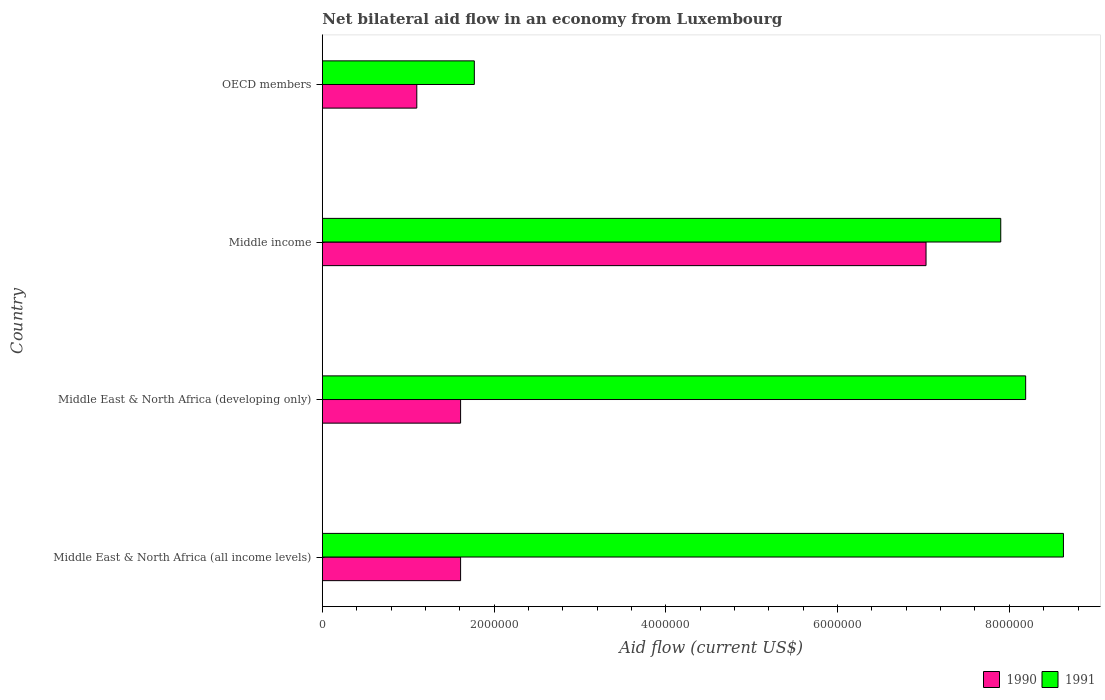How many different coloured bars are there?
Your answer should be compact. 2. How many groups of bars are there?
Your answer should be compact. 4. Are the number of bars per tick equal to the number of legend labels?
Give a very brief answer. Yes. How many bars are there on the 2nd tick from the bottom?
Provide a short and direct response. 2. What is the label of the 4th group of bars from the top?
Keep it short and to the point. Middle East & North Africa (all income levels). What is the net bilateral aid flow in 1991 in OECD members?
Your response must be concise. 1.77e+06. Across all countries, what is the maximum net bilateral aid flow in 1990?
Ensure brevity in your answer.  7.03e+06. Across all countries, what is the minimum net bilateral aid flow in 1990?
Ensure brevity in your answer.  1.10e+06. In which country was the net bilateral aid flow in 1990 maximum?
Offer a very short reply. Middle income. In which country was the net bilateral aid flow in 1991 minimum?
Offer a very short reply. OECD members. What is the total net bilateral aid flow in 1991 in the graph?
Provide a succinct answer. 2.65e+07. What is the difference between the net bilateral aid flow in 1991 in Middle East & North Africa (developing only) and that in OECD members?
Keep it short and to the point. 6.42e+06. What is the difference between the net bilateral aid flow in 1991 in Middle East & North Africa (all income levels) and the net bilateral aid flow in 1990 in Middle East & North Africa (developing only)?
Provide a short and direct response. 7.02e+06. What is the average net bilateral aid flow in 1991 per country?
Your response must be concise. 6.62e+06. What is the difference between the net bilateral aid flow in 1991 and net bilateral aid flow in 1990 in Middle East & North Africa (all income levels)?
Provide a succinct answer. 7.02e+06. In how many countries, is the net bilateral aid flow in 1990 greater than 2800000 US$?
Keep it short and to the point. 1. What is the ratio of the net bilateral aid flow in 1990 in Middle East & North Africa (developing only) to that in Middle income?
Your answer should be compact. 0.23. Is the net bilateral aid flow in 1990 in Middle East & North Africa (all income levels) less than that in Middle East & North Africa (developing only)?
Keep it short and to the point. No. Is the difference between the net bilateral aid flow in 1991 in Middle East & North Africa (all income levels) and OECD members greater than the difference between the net bilateral aid flow in 1990 in Middle East & North Africa (all income levels) and OECD members?
Offer a terse response. Yes. What is the difference between the highest and the lowest net bilateral aid flow in 1991?
Give a very brief answer. 6.86e+06. Is the sum of the net bilateral aid flow in 1990 in Middle income and OECD members greater than the maximum net bilateral aid flow in 1991 across all countries?
Offer a very short reply. No. How many countries are there in the graph?
Offer a very short reply. 4. Are the values on the major ticks of X-axis written in scientific E-notation?
Your response must be concise. No. Does the graph contain any zero values?
Make the answer very short. No. Does the graph contain grids?
Provide a succinct answer. No. Where does the legend appear in the graph?
Your response must be concise. Bottom right. How many legend labels are there?
Provide a short and direct response. 2. How are the legend labels stacked?
Offer a terse response. Horizontal. What is the title of the graph?
Offer a very short reply. Net bilateral aid flow in an economy from Luxembourg. What is the label or title of the X-axis?
Offer a very short reply. Aid flow (current US$). What is the label or title of the Y-axis?
Your response must be concise. Country. What is the Aid flow (current US$) in 1990 in Middle East & North Africa (all income levels)?
Your answer should be very brief. 1.61e+06. What is the Aid flow (current US$) of 1991 in Middle East & North Africa (all income levels)?
Your answer should be compact. 8.63e+06. What is the Aid flow (current US$) in 1990 in Middle East & North Africa (developing only)?
Your answer should be compact. 1.61e+06. What is the Aid flow (current US$) of 1991 in Middle East & North Africa (developing only)?
Your response must be concise. 8.19e+06. What is the Aid flow (current US$) in 1990 in Middle income?
Keep it short and to the point. 7.03e+06. What is the Aid flow (current US$) of 1991 in Middle income?
Provide a succinct answer. 7.90e+06. What is the Aid flow (current US$) of 1990 in OECD members?
Your answer should be compact. 1.10e+06. What is the Aid flow (current US$) of 1991 in OECD members?
Provide a succinct answer. 1.77e+06. Across all countries, what is the maximum Aid flow (current US$) of 1990?
Your response must be concise. 7.03e+06. Across all countries, what is the maximum Aid flow (current US$) of 1991?
Offer a terse response. 8.63e+06. Across all countries, what is the minimum Aid flow (current US$) in 1990?
Your response must be concise. 1.10e+06. Across all countries, what is the minimum Aid flow (current US$) in 1991?
Make the answer very short. 1.77e+06. What is the total Aid flow (current US$) of 1990 in the graph?
Ensure brevity in your answer.  1.14e+07. What is the total Aid flow (current US$) of 1991 in the graph?
Offer a very short reply. 2.65e+07. What is the difference between the Aid flow (current US$) in 1991 in Middle East & North Africa (all income levels) and that in Middle East & North Africa (developing only)?
Provide a succinct answer. 4.40e+05. What is the difference between the Aid flow (current US$) of 1990 in Middle East & North Africa (all income levels) and that in Middle income?
Provide a succinct answer. -5.42e+06. What is the difference between the Aid flow (current US$) in 1991 in Middle East & North Africa (all income levels) and that in Middle income?
Your response must be concise. 7.30e+05. What is the difference between the Aid flow (current US$) in 1990 in Middle East & North Africa (all income levels) and that in OECD members?
Your answer should be very brief. 5.10e+05. What is the difference between the Aid flow (current US$) in 1991 in Middle East & North Africa (all income levels) and that in OECD members?
Your answer should be compact. 6.86e+06. What is the difference between the Aid flow (current US$) of 1990 in Middle East & North Africa (developing only) and that in Middle income?
Your answer should be compact. -5.42e+06. What is the difference between the Aid flow (current US$) of 1991 in Middle East & North Africa (developing only) and that in Middle income?
Your answer should be compact. 2.90e+05. What is the difference between the Aid flow (current US$) in 1990 in Middle East & North Africa (developing only) and that in OECD members?
Offer a terse response. 5.10e+05. What is the difference between the Aid flow (current US$) of 1991 in Middle East & North Africa (developing only) and that in OECD members?
Keep it short and to the point. 6.42e+06. What is the difference between the Aid flow (current US$) of 1990 in Middle income and that in OECD members?
Make the answer very short. 5.93e+06. What is the difference between the Aid flow (current US$) of 1991 in Middle income and that in OECD members?
Offer a terse response. 6.13e+06. What is the difference between the Aid flow (current US$) of 1990 in Middle East & North Africa (all income levels) and the Aid flow (current US$) of 1991 in Middle East & North Africa (developing only)?
Offer a very short reply. -6.58e+06. What is the difference between the Aid flow (current US$) of 1990 in Middle East & North Africa (all income levels) and the Aid flow (current US$) of 1991 in Middle income?
Offer a very short reply. -6.29e+06. What is the difference between the Aid flow (current US$) in 1990 in Middle East & North Africa (developing only) and the Aid flow (current US$) in 1991 in Middle income?
Ensure brevity in your answer.  -6.29e+06. What is the difference between the Aid flow (current US$) in 1990 in Middle income and the Aid flow (current US$) in 1991 in OECD members?
Keep it short and to the point. 5.26e+06. What is the average Aid flow (current US$) in 1990 per country?
Make the answer very short. 2.84e+06. What is the average Aid flow (current US$) in 1991 per country?
Your response must be concise. 6.62e+06. What is the difference between the Aid flow (current US$) in 1990 and Aid flow (current US$) in 1991 in Middle East & North Africa (all income levels)?
Your answer should be very brief. -7.02e+06. What is the difference between the Aid flow (current US$) of 1990 and Aid flow (current US$) of 1991 in Middle East & North Africa (developing only)?
Ensure brevity in your answer.  -6.58e+06. What is the difference between the Aid flow (current US$) of 1990 and Aid flow (current US$) of 1991 in Middle income?
Make the answer very short. -8.70e+05. What is the difference between the Aid flow (current US$) in 1990 and Aid flow (current US$) in 1991 in OECD members?
Your answer should be compact. -6.70e+05. What is the ratio of the Aid flow (current US$) in 1991 in Middle East & North Africa (all income levels) to that in Middle East & North Africa (developing only)?
Offer a terse response. 1.05. What is the ratio of the Aid flow (current US$) in 1990 in Middle East & North Africa (all income levels) to that in Middle income?
Your answer should be compact. 0.23. What is the ratio of the Aid flow (current US$) of 1991 in Middle East & North Africa (all income levels) to that in Middle income?
Provide a succinct answer. 1.09. What is the ratio of the Aid flow (current US$) of 1990 in Middle East & North Africa (all income levels) to that in OECD members?
Keep it short and to the point. 1.46. What is the ratio of the Aid flow (current US$) of 1991 in Middle East & North Africa (all income levels) to that in OECD members?
Make the answer very short. 4.88. What is the ratio of the Aid flow (current US$) in 1990 in Middle East & North Africa (developing only) to that in Middle income?
Provide a succinct answer. 0.23. What is the ratio of the Aid flow (current US$) in 1991 in Middle East & North Africa (developing only) to that in Middle income?
Keep it short and to the point. 1.04. What is the ratio of the Aid flow (current US$) of 1990 in Middle East & North Africa (developing only) to that in OECD members?
Offer a terse response. 1.46. What is the ratio of the Aid flow (current US$) in 1991 in Middle East & North Africa (developing only) to that in OECD members?
Provide a short and direct response. 4.63. What is the ratio of the Aid flow (current US$) in 1990 in Middle income to that in OECD members?
Your answer should be compact. 6.39. What is the ratio of the Aid flow (current US$) of 1991 in Middle income to that in OECD members?
Keep it short and to the point. 4.46. What is the difference between the highest and the second highest Aid flow (current US$) of 1990?
Provide a succinct answer. 5.42e+06. What is the difference between the highest and the lowest Aid flow (current US$) of 1990?
Your response must be concise. 5.93e+06. What is the difference between the highest and the lowest Aid flow (current US$) of 1991?
Your response must be concise. 6.86e+06. 